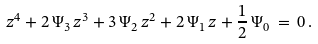<formula> <loc_0><loc_0><loc_500><loc_500>z ^ { 4 } + 2 \, \Psi _ { 3 } \, z ^ { 3 } + 3 \, \Psi _ { 2 } \, z ^ { 2 } + 2 \, \Psi _ { 1 } \, z + \frac { 1 } { 2 } \, \Psi _ { 0 } \, = \, 0 \, .</formula> 